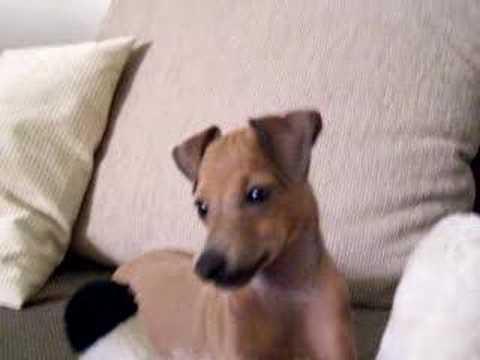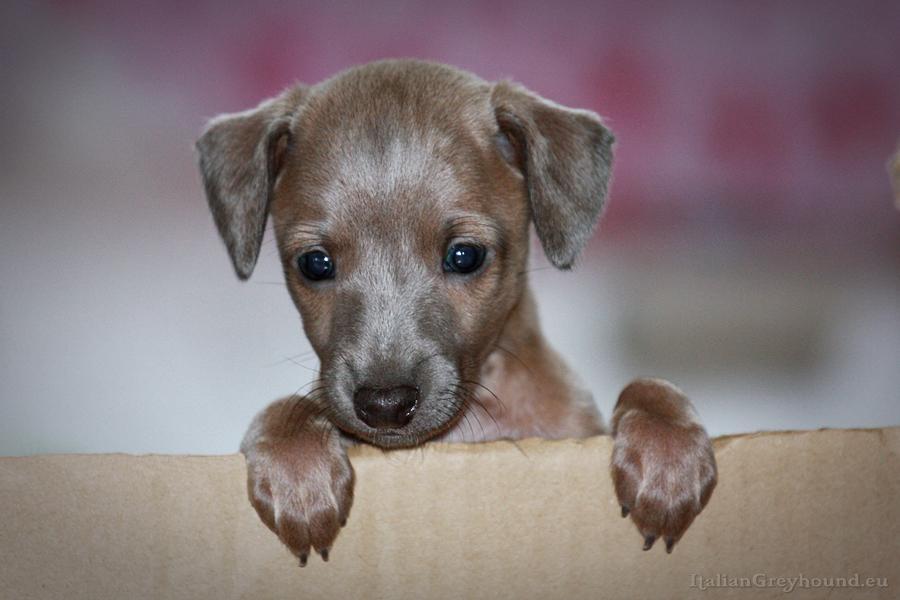The first image is the image on the left, the second image is the image on the right. For the images displayed, is the sentence "An image shows at least three dogs inside some type of container." factually correct? Answer yes or no. No. 